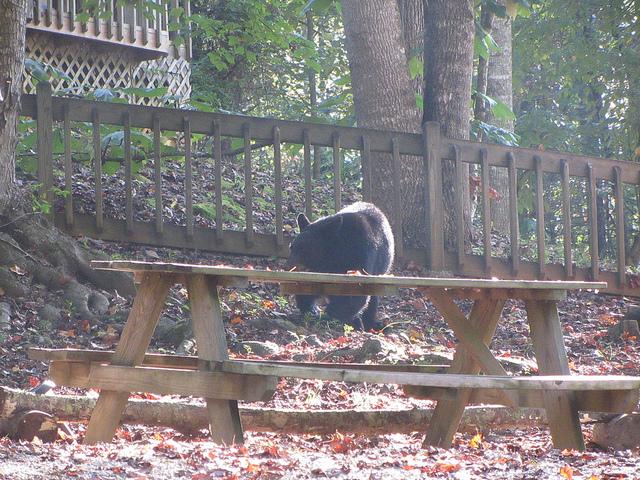What is in the top left corner?
Short answer required. Deck. What is the fence made out of?
Give a very brief answer. Wood. What is on the picnic table?
Write a very short answer. Bear. 